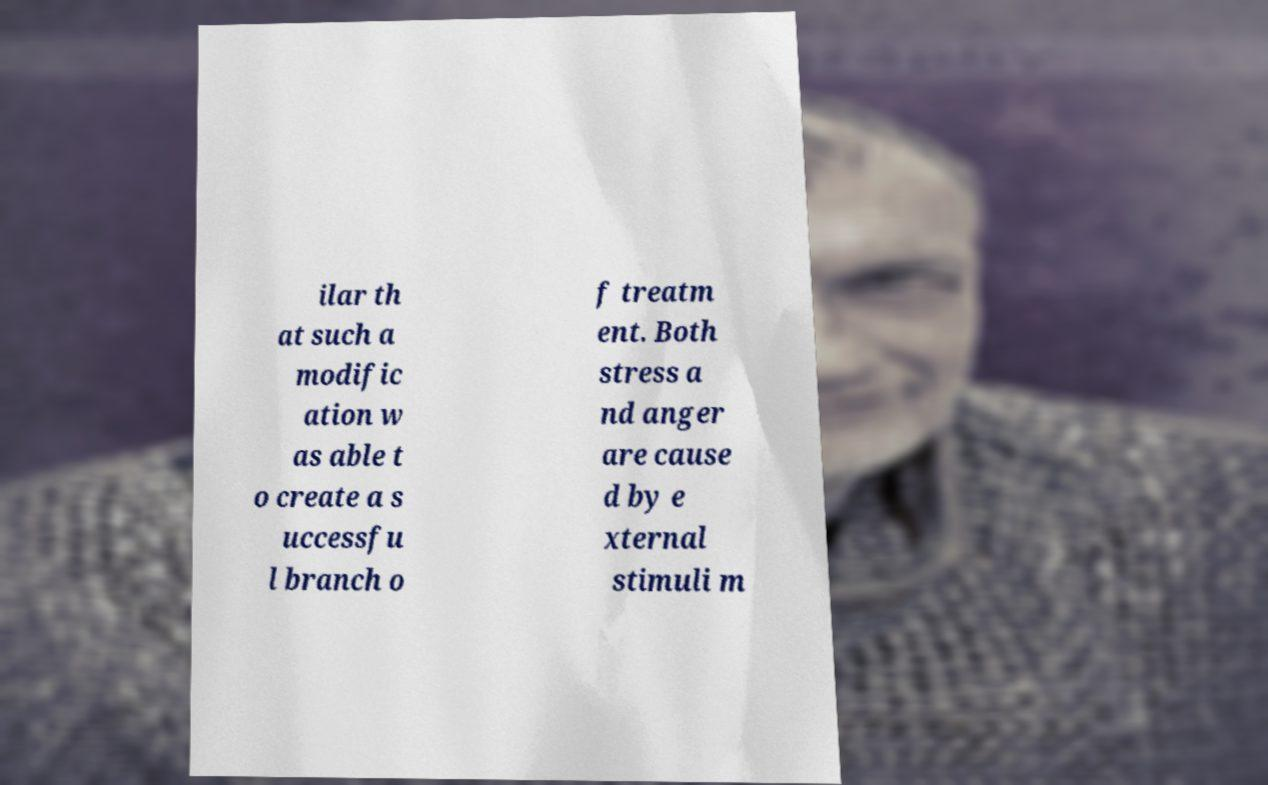Can you read and provide the text displayed in the image?This photo seems to have some interesting text. Can you extract and type it out for me? ilar th at such a modific ation w as able t o create a s uccessfu l branch o f treatm ent. Both stress a nd anger are cause d by e xternal stimuli m 